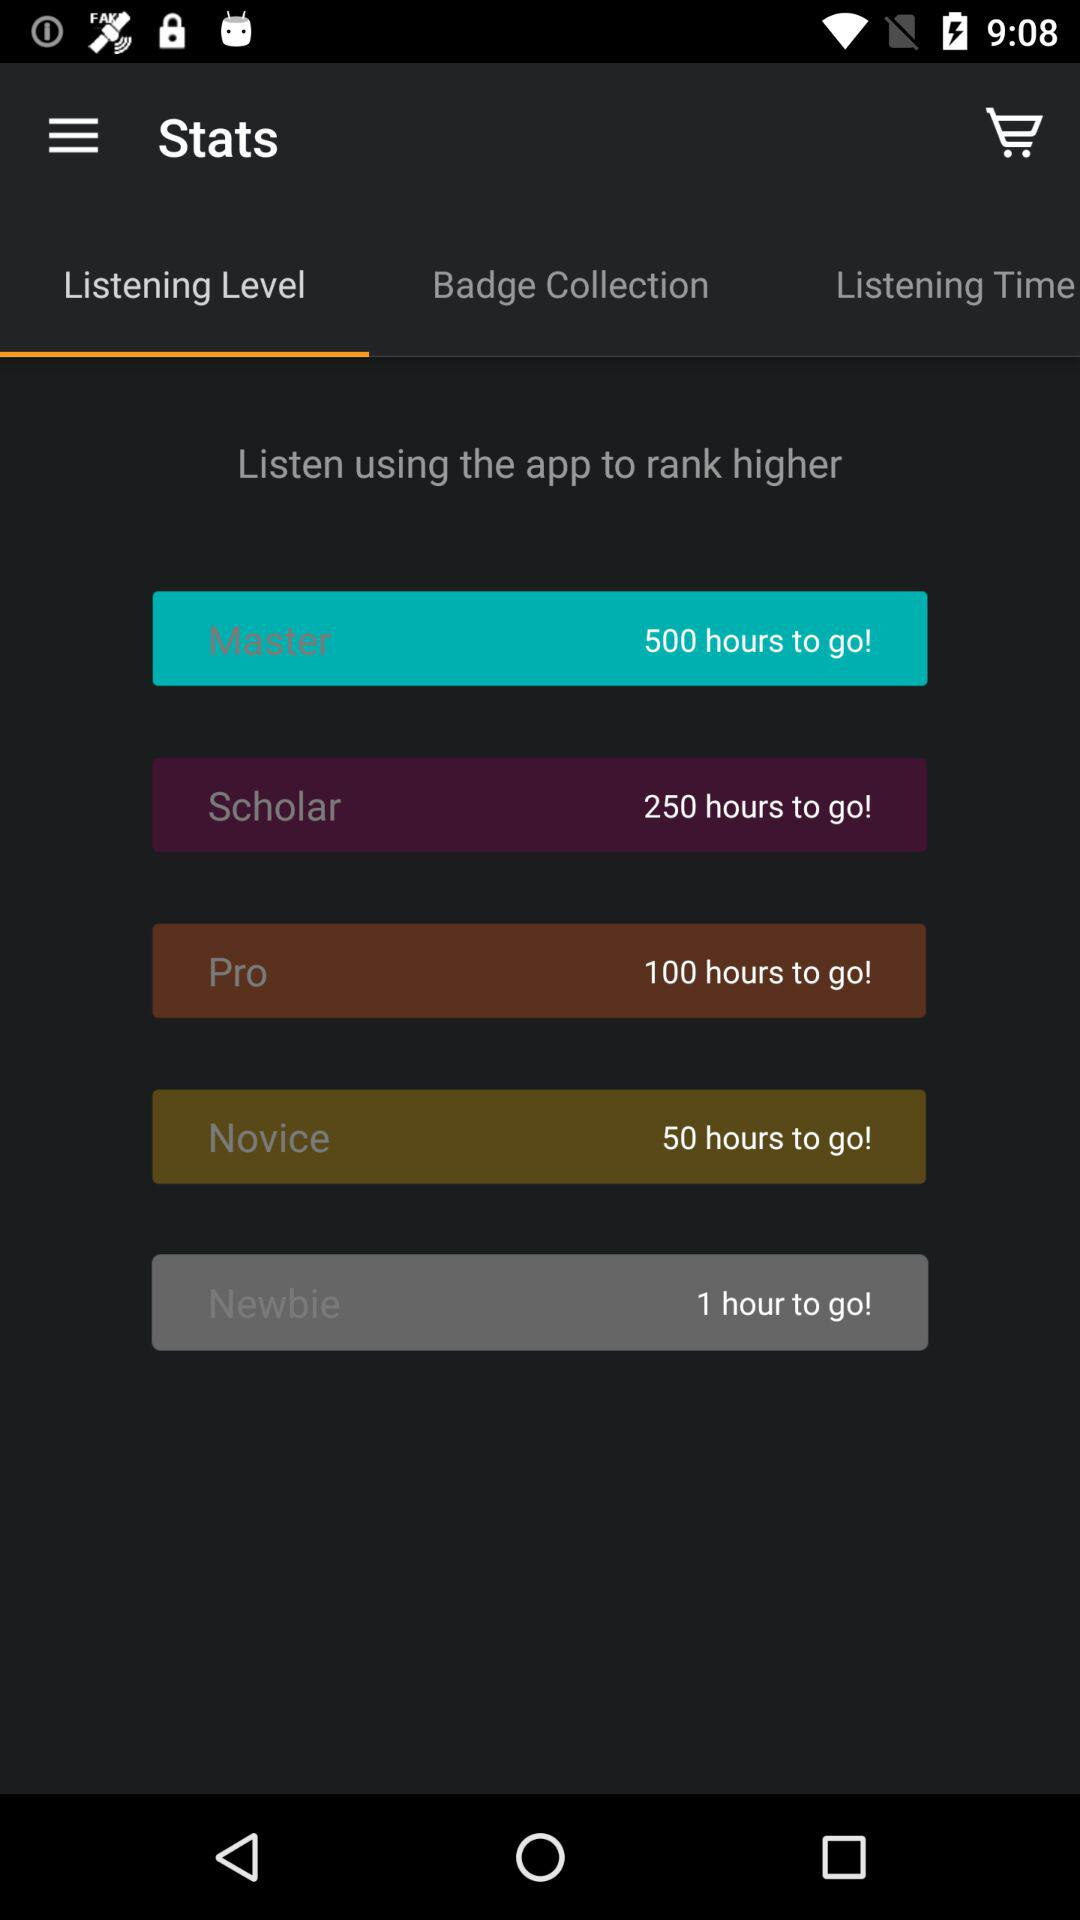How many hours to go to reach the Newbie level?
Answer the question using a single word or phrase. 1 